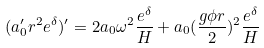Convert formula to latex. <formula><loc_0><loc_0><loc_500><loc_500>( a _ { 0 } ^ { \prime } r ^ { 2 } e ^ { \delta } ) ^ { \prime } = 2 a _ { 0 } \omega ^ { 2 } \frac { e ^ { \delta } } { H } + a _ { 0 } ( \frac { g \phi r } { 2 } ) ^ { 2 } \frac { e ^ { \delta } } { H }</formula> 